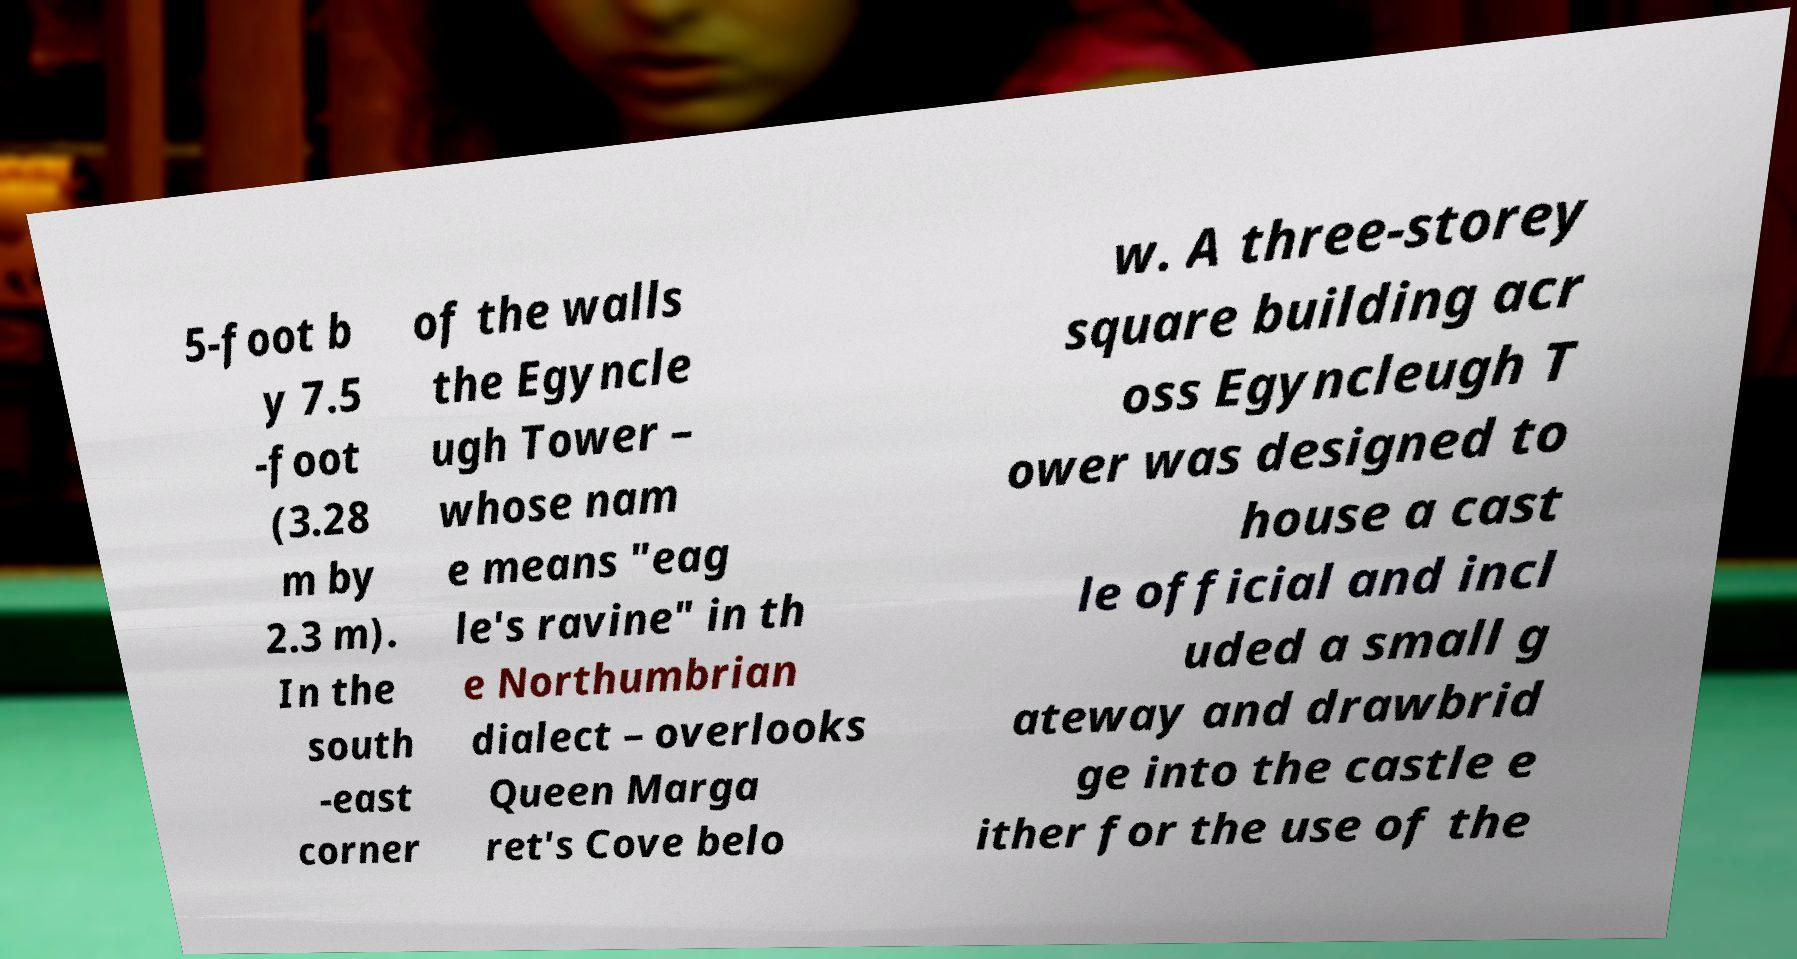Can you read and provide the text displayed in the image?This photo seems to have some interesting text. Can you extract and type it out for me? 5-foot b y 7.5 -foot (3.28 m by 2.3 m). In the south -east corner of the walls the Egyncle ugh Tower – whose nam e means "eag le's ravine" in th e Northumbrian dialect – overlooks Queen Marga ret's Cove belo w. A three-storey square building acr oss Egyncleugh T ower was designed to house a cast le official and incl uded a small g ateway and drawbrid ge into the castle e ither for the use of the 